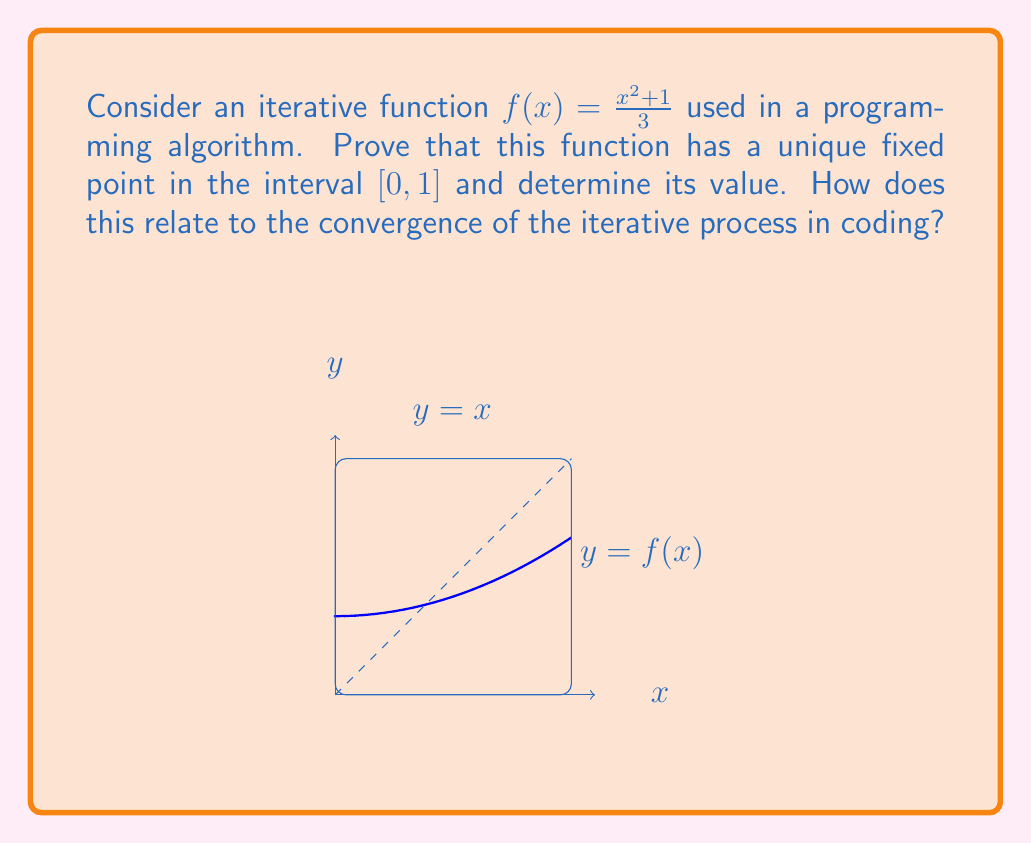Help me with this question. To prove the existence and uniqueness of a fixed point for $f(x) = \frac{x^2 + 1}{3}$ in $[0,1]$, we'll use the Banach Fixed Point Theorem:

1. First, we show that $f$ maps $[0,1]$ to itself:
   For $x \in [0,1]$, $0 \leq x^2 \leq 1$, so $1 \leq x^2 + 1 \leq 2$
   Thus, $\frac{1}{3} \leq f(x) \leq \frac{2}{3} < 1$

2. Next, we prove that $f$ is a contraction mapping:
   $|f'(x)| = |\frac{2x}{3}| \leq \frac{2}{3} < 1$ for $x \in [0,1]$

3. By the Banach Fixed Point Theorem, $f$ has a unique fixed point in $[0,1]$.

To find the fixed point:
$$x = f(x) = \frac{x^2 + 1}{3}$$
$$3x = x^2 + 1$$
$$x^2 - 3x + 1 = 0$$
Using the quadratic formula:
$$x = \frac{3 \pm \sqrt{9 - 4}}{2} = \frac{3 \pm \sqrt{5}}{2}$$

The solution in $[0,1]$ is $x = \frac{3 - \sqrt{5}}{2} \approx 0.382$.

This relates to convergence in coding as it guarantees that iterative applications of $f$ will converge to this fixed point, regardless of the starting value in $[0,1]$. This property is crucial for ensuring the stability and predictability of iterative algorithms.
Answer: $\frac{3 - \sqrt{5}}{2}$ 